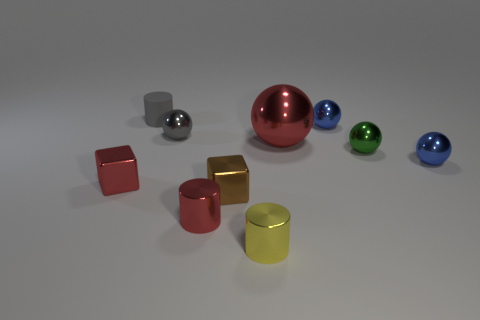Is there any other thing that is the same size as the red sphere?
Make the answer very short. No. There is a shiny sphere on the left side of the big red metal object; is it the same color as the cylinder behind the small brown cube?
Your answer should be very brief. Yes. What color is the big sphere to the left of the blue metal object in front of the tiny blue shiny object left of the green ball?
Offer a very short reply. Red. There is a tiny blue sphere in front of the tiny gray sphere; is there a tiny blue thing that is left of it?
Provide a succinct answer. Yes. Does the gray object that is on the right side of the gray cylinder have the same shape as the tiny green metallic thing?
Your answer should be compact. Yes. Is there any other thing that has the same shape as the small matte thing?
Keep it short and to the point. Yes. How many blocks are matte objects or green metal things?
Ensure brevity in your answer.  0. How many small red cylinders are there?
Your answer should be compact. 1. What size is the blue thing on the right side of the blue metal sphere behind the tiny green metal thing?
Your answer should be very brief. Small. What number of other things are there of the same size as the rubber cylinder?
Your answer should be compact. 8. 